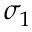Convert formula to latex. <formula><loc_0><loc_0><loc_500><loc_500>\sigma _ { 1 }</formula> 